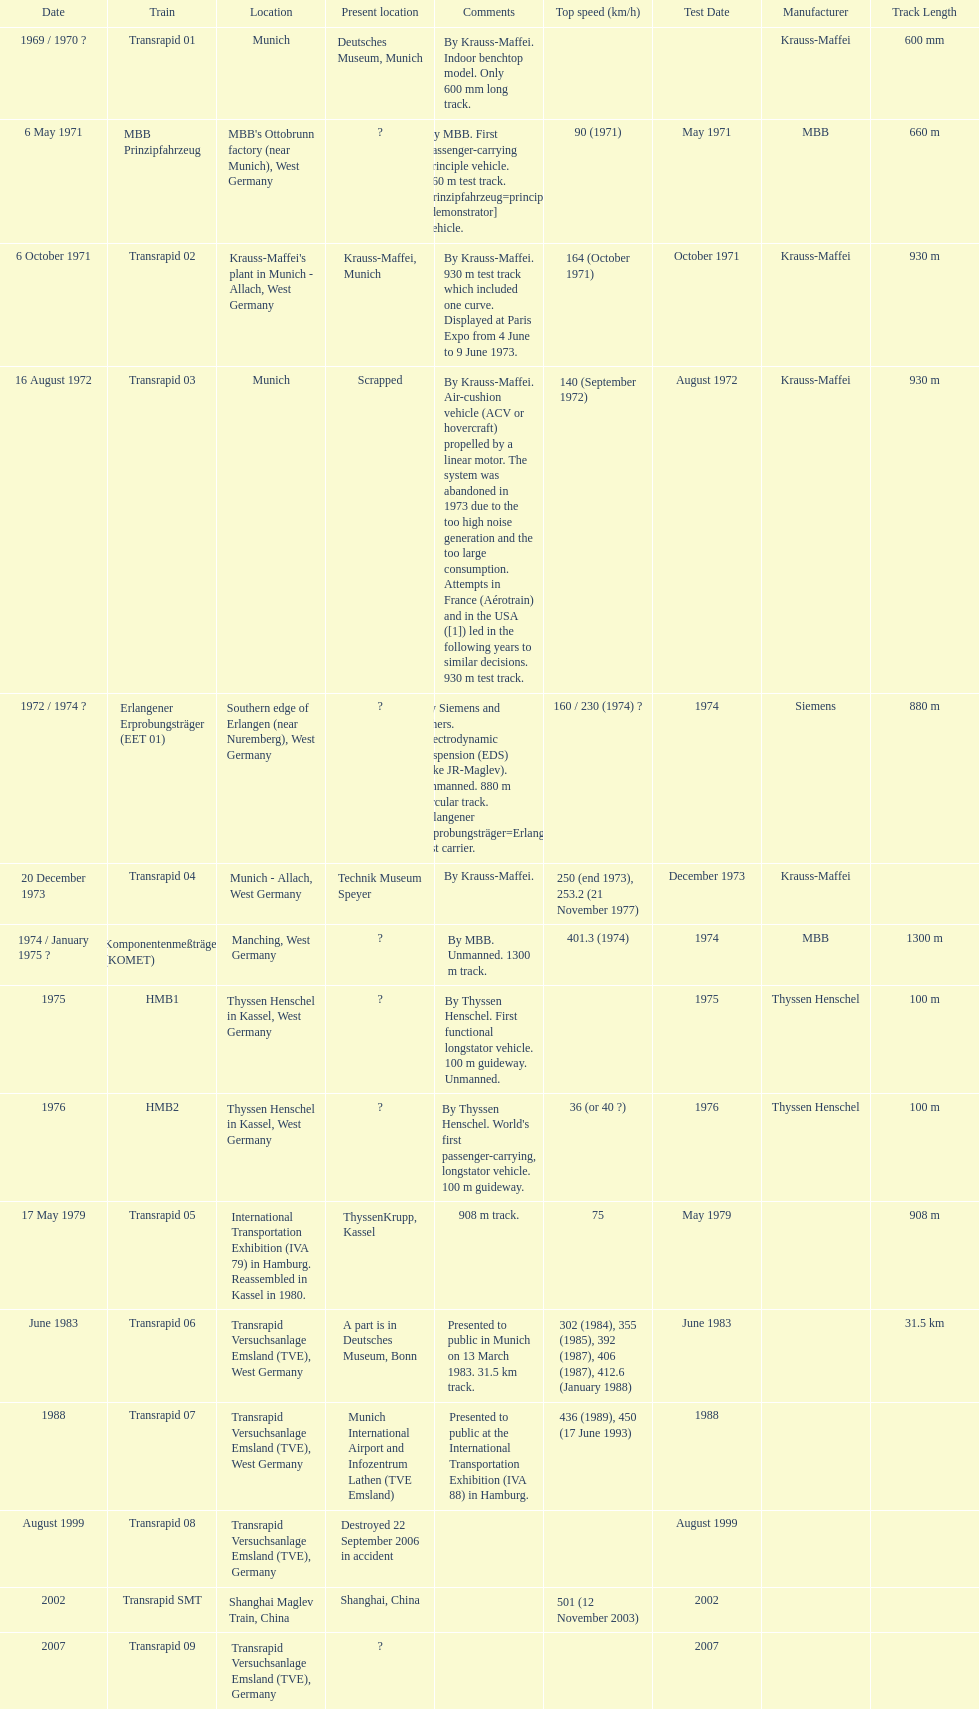What is the number of trains that were either scrapped or destroyed? 2. 